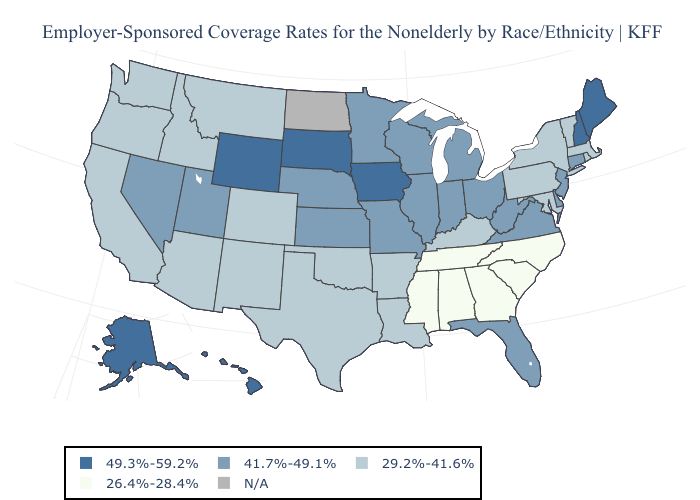Among the states that border New Mexico , does Utah have the lowest value?
Answer briefly. No. Name the states that have a value in the range N/A?
Concise answer only. North Dakota. Name the states that have a value in the range 49.3%-59.2%?
Answer briefly. Alaska, Hawaii, Iowa, Maine, New Hampshire, South Dakota, Wyoming. Name the states that have a value in the range 49.3%-59.2%?
Quick response, please. Alaska, Hawaii, Iowa, Maine, New Hampshire, South Dakota, Wyoming. Which states have the lowest value in the South?
Keep it brief. Alabama, Georgia, Mississippi, North Carolina, South Carolina, Tennessee. What is the value of Rhode Island?
Concise answer only. 29.2%-41.6%. What is the value of Vermont?
Keep it brief. 29.2%-41.6%. Name the states that have a value in the range 29.2%-41.6%?
Answer briefly. Arizona, Arkansas, California, Colorado, Idaho, Kentucky, Louisiana, Maryland, Massachusetts, Montana, New Mexico, New York, Oklahoma, Oregon, Pennsylvania, Rhode Island, Texas, Vermont, Washington. Name the states that have a value in the range N/A?
Short answer required. North Dakota. Is the legend a continuous bar?
Answer briefly. No. What is the value of North Dakota?
Write a very short answer. N/A. Does the first symbol in the legend represent the smallest category?
Keep it brief. No. What is the value of Kentucky?
Quick response, please. 29.2%-41.6%. What is the lowest value in the USA?
Answer briefly. 26.4%-28.4%. 